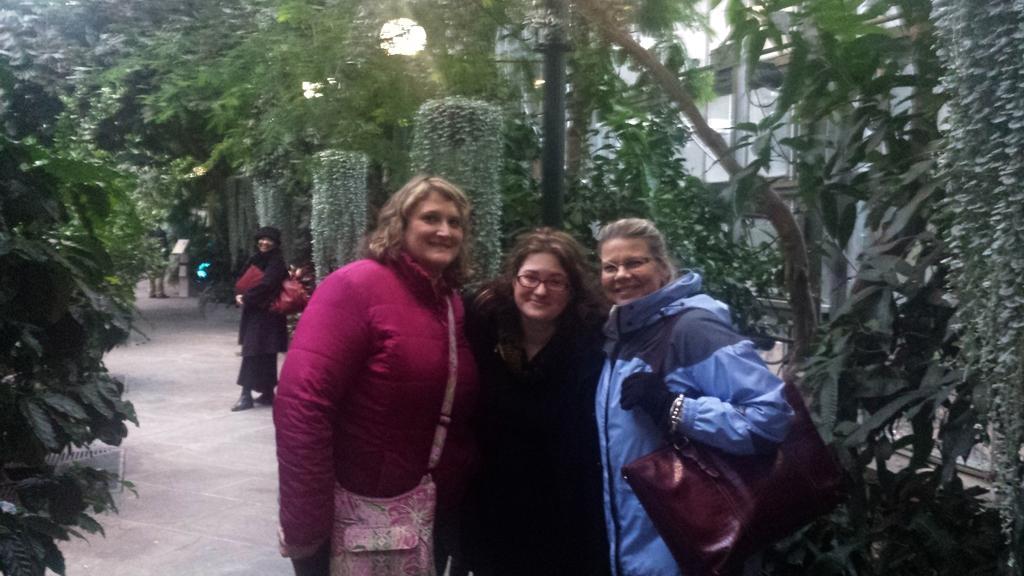Can you describe this image briefly? In this picture we can observe three women standing. All of them were smiling. Two of the women were holding bags on their shoulders. There are some plants and trees. We can observe lamps to the poles. In the background there is a building. 